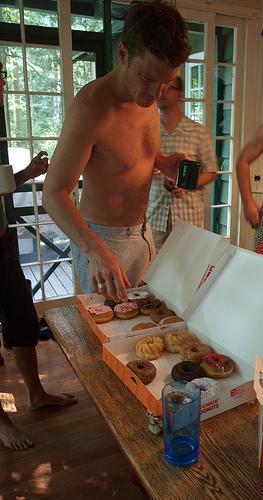How many boxes are on the table?
Give a very brief answer. 2. 